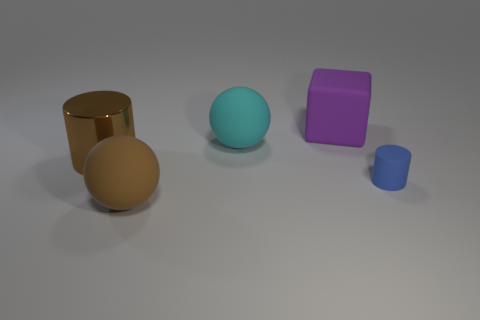Are there any other things that are the same size as the blue cylinder?
Make the answer very short. No. The matte thing that is the same shape as the brown metal thing is what color?
Offer a terse response. Blue. Does the big metal cylinder have the same color as the big cube?
Provide a short and direct response. No. What is the size of the cylinder that is on the left side of the cyan object?
Make the answer very short. Large. Do the ball in front of the blue rubber cylinder and the cylinder that is to the left of the large matte cube have the same color?
Ensure brevity in your answer.  Yes. How many other objects are the same shape as the large purple object?
Make the answer very short. 0. Are there an equal number of purple cubes that are to the left of the cyan object and small matte cylinders right of the big purple object?
Give a very brief answer. No. Is the material of the sphere that is behind the metallic cylinder the same as the big brown thing that is in front of the rubber cylinder?
Your answer should be compact. Yes. How many other things are there of the same size as the blue matte cylinder?
Your answer should be very brief. 0. How many objects are big red spheres or large rubber objects that are behind the big brown matte sphere?
Provide a succinct answer. 2. 